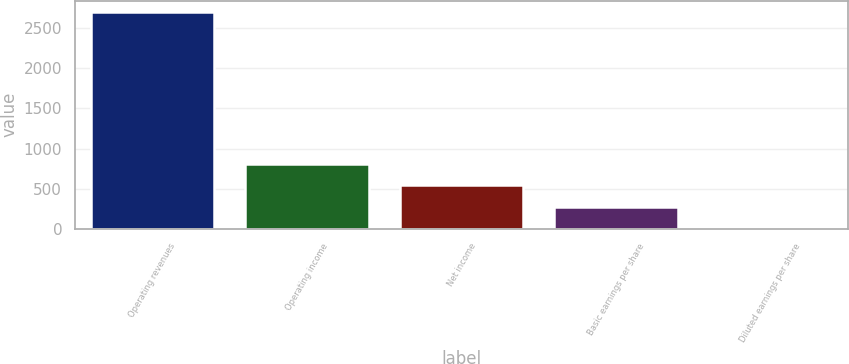Convert chart. <chart><loc_0><loc_0><loc_500><loc_500><bar_chart><fcel>Operating revenues<fcel>Operating income<fcel>Net income<fcel>Basic earnings per share<fcel>Diluted earnings per share<nl><fcel>2707<fcel>812.56<fcel>541.93<fcel>271.3<fcel>0.67<nl></chart> 